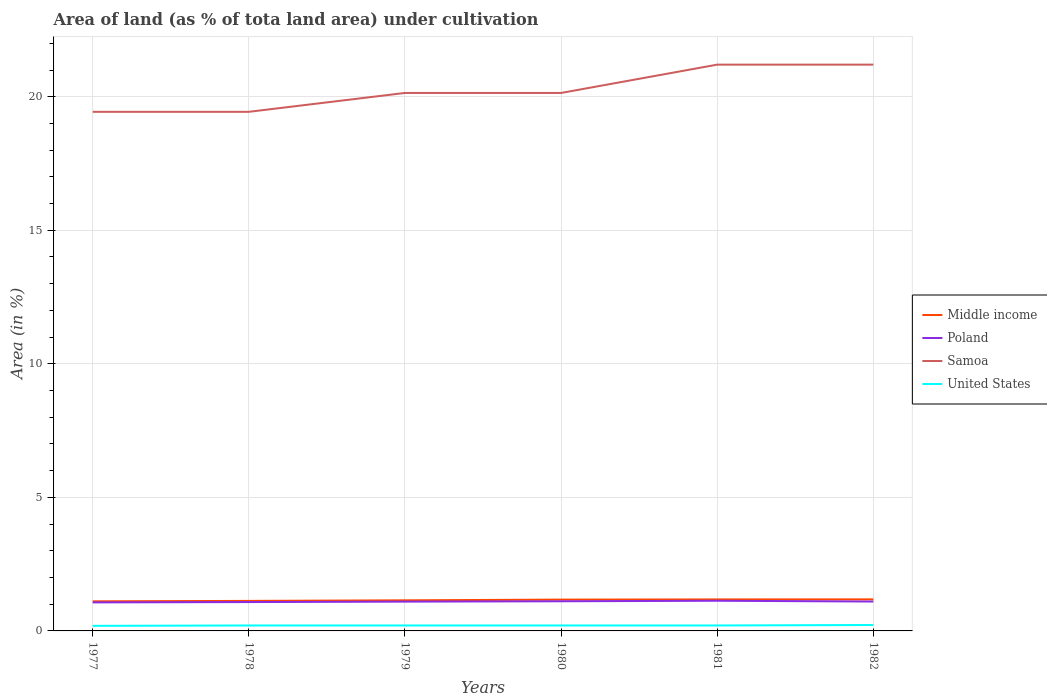How many different coloured lines are there?
Make the answer very short. 4. Does the line corresponding to United States intersect with the line corresponding to Poland?
Offer a terse response. No. Across all years, what is the maximum percentage of land under cultivation in United States?
Your answer should be compact. 0.19. What is the total percentage of land under cultivation in Samoa in the graph?
Your answer should be very brief. -0.71. What is the difference between the highest and the second highest percentage of land under cultivation in Poland?
Offer a very short reply. 0.06. What is the difference between the highest and the lowest percentage of land under cultivation in Middle income?
Offer a very short reply. 3. How many lines are there?
Keep it short and to the point. 4. How many years are there in the graph?
Make the answer very short. 6. Does the graph contain any zero values?
Ensure brevity in your answer.  No. How many legend labels are there?
Ensure brevity in your answer.  4. What is the title of the graph?
Offer a very short reply. Area of land (as % of tota land area) under cultivation. Does "Rwanda" appear as one of the legend labels in the graph?
Keep it short and to the point. No. What is the label or title of the X-axis?
Offer a terse response. Years. What is the label or title of the Y-axis?
Offer a terse response. Area (in %). What is the Area (in %) in Middle income in 1977?
Offer a very short reply. 1.11. What is the Area (in %) in Poland in 1977?
Provide a short and direct response. 1.07. What is the Area (in %) in Samoa in 1977?
Provide a succinct answer. 19.43. What is the Area (in %) of United States in 1977?
Your response must be concise. 0.19. What is the Area (in %) of Middle income in 1978?
Keep it short and to the point. 1.12. What is the Area (in %) in Poland in 1978?
Offer a terse response. 1.08. What is the Area (in %) of Samoa in 1978?
Make the answer very short. 19.43. What is the Area (in %) in United States in 1978?
Offer a terse response. 0.2. What is the Area (in %) of Middle income in 1979?
Keep it short and to the point. 1.15. What is the Area (in %) in Poland in 1979?
Offer a very short reply. 1.1. What is the Area (in %) of Samoa in 1979?
Keep it short and to the point. 20.14. What is the Area (in %) of United States in 1979?
Provide a short and direct response. 0.2. What is the Area (in %) in Middle income in 1980?
Your answer should be compact. 1.17. What is the Area (in %) in Poland in 1980?
Your answer should be very brief. 1.11. What is the Area (in %) of Samoa in 1980?
Keep it short and to the point. 20.14. What is the Area (in %) in United States in 1980?
Ensure brevity in your answer.  0.2. What is the Area (in %) of Middle income in 1981?
Your answer should be very brief. 1.18. What is the Area (in %) in Poland in 1981?
Provide a short and direct response. 1.13. What is the Area (in %) in Samoa in 1981?
Give a very brief answer. 21.2. What is the Area (in %) in United States in 1981?
Offer a terse response. 0.2. What is the Area (in %) of Middle income in 1982?
Offer a very short reply. 1.18. What is the Area (in %) of Poland in 1982?
Provide a succinct answer. 1.1. What is the Area (in %) in Samoa in 1982?
Provide a succinct answer. 21.2. What is the Area (in %) of United States in 1982?
Offer a terse response. 0.22. Across all years, what is the maximum Area (in %) in Middle income?
Offer a terse response. 1.18. Across all years, what is the maximum Area (in %) of Poland?
Offer a very short reply. 1.13. Across all years, what is the maximum Area (in %) in Samoa?
Offer a very short reply. 21.2. Across all years, what is the maximum Area (in %) of United States?
Keep it short and to the point. 0.22. Across all years, what is the minimum Area (in %) in Middle income?
Keep it short and to the point. 1.11. Across all years, what is the minimum Area (in %) in Poland?
Offer a terse response. 1.07. Across all years, what is the minimum Area (in %) of Samoa?
Offer a terse response. 19.43. Across all years, what is the minimum Area (in %) of United States?
Offer a very short reply. 0.19. What is the total Area (in %) of Middle income in the graph?
Your answer should be compact. 6.91. What is the total Area (in %) in Poland in the graph?
Your response must be concise. 6.59. What is the total Area (in %) of Samoa in the graph?
Offer a terse response. 121.55. What is the total Area (in %) of United States in the graph?
Your answer should be compact. 1.23. What is the difference between the Area (in %) in Middle income in 1977 and that in 1978?
Ensure brevity in your answer.  -0.02. What is the difference between the Area (in %) in Poland in 1977 and that in 1978?
Offer a terse response. -0.01. What is the difference between the Area (in %) of Samoa in 1977 and that in 1978?
Provide a short and direct response. 0. What is the difference between the Area (in %) of United States in 1977 and that in 1978?
Your answer should be very brief. -0.01. What is the difference between the Area (in %) in Middle income in 1977 and that in 1979?
Your response must be concise. -0.04. What is the difference between the Area (in %) of Poland in 1977 and that in 1979?
Ensure brevity in your answer.  -0.03. What is the difference between the Area (in %) of Samoa in 1977 and that in 1979?
Your answer should be very brief. -0.71. What is the difference between the Area (in %) of United States in 1977 and that in 1979?
Make the answer very short. -0.01. What is the difference between the Area (in %) in Middle income in 1977 and that in 1980?
Give a very brief answer. -0.06. What is the difference between the Area (in %) of Poland in 1977 and that in 1980?
Offer a very short reply. -0.04. What is the difference between the Area (in %) of Samoa in 1977 and that in 1980?
Your answer should be compact. -0.71. What is the difference between the Area (in %) of United States in 1977 and that in 1980?
Your answer should be compact. -0.01. What is the difference between the Area (in %) in Middle income in 1977 and that in 1981?
Ensure brevity in your answer.  -0.07. What is the difference between the Area (in %) of Poland in 1977 and that in 1981?
Your response must be concise. -0.06. What is the difference between the Area (in %) of Samoa in 1977 and that in 1981?
Offer a very short reply. -1.77. What is the difference between the Area (in %) in United States in 1977 and that in 1981?
Your answer should be compact. -0.01. What is the difference between the Area (in %) in Middle income in 1977 and that in 1982?
Give a very brief answer. -0.07. What is the difference between the Area (in %) in Poland in 1977 and that in 1982?
Give a very brief answer. -0.03. What is the difference between the Area (in %) of Samoa in 1977 and that in 1982?
Provide a succinct answer. -1.77. What is the difference between the Area (in %) in United States in 1977 and that in 1982?
Your response must be concise. -0.03. What is the difference between the Area (in %) of Middle income in 1978 and that in 1979?
Keep it short and to the point. -0.02. What is the difference between the Area (in %) of Poland in 1978 and that in 1979?
Keep it short and to the point. -0.02. What is the difference between the Area (in %) of Samoa in 1978 and that in 1979?
Your answer should be very brief. -0.71. What is the difference between the Area (in %) of United States in 1978 and that in 1979?
Your answer should be very brief. 0. What is the difference between the Area (in %) of Middle income in 1978 and that in 1980?
Provide a succinct answer. -0.05. What is the difference between the Area (in %) of Poland in 1978 and that in 1980?
Your answer should be very brief. -0.03. What is the difference between the Area (in %) of Samoa in 1978 and that in 1980?
Provide a short and direct response. -0.71. What is the difference between the Area (in %) of Middle income in 1978 and that in 1981?
Your answer should be compact. -0.06. What is the difference between the Area (in %) in Poland in 1978 and that in 1981?
Give a very brief answer. -0.05. What is the difference between the Area (in %) of Samoa in 1978 and that in 1981?
Your answer should be compact. -1.77. What is the difference between the Area (in %) of Middle income in 1978 and that in 1982?
Your answer should be compact. -0.06. What is the difference between the Area (in %) of Poland in 1978 and that in 1982?
Offer a terse response. -0.02. What is the difference between the Area (in %) of Samoa in 1978 and that in 1982?
Provide a short and direct response. -1.77. What is the difference between the Area (in %) of United States in 1978 and that in 1982?
Your answer should be compact. -0.02. What is the difference between the Area (in %) of Middle income in 1979 and that in 1980?
Your answer should be compact. -0.03. What is the difference between the Area (in %) of Poland in 1979 and that in 1980?
Your answer should be compact. -0.01. What is the difference between the Area (in %) in United States in 1979 and that in 1980?
Offer a terse response. 0. What is the difference between the Area (in %) in Middle income in 1979 and that in 1981?
Your response must be concise. -0.03. What is the difference between the Area (in %) of Poland in 1979 and that in 1981?
Make the answer very short. -0.03. What is the difference between the Area (in %) of Samoa in 1979 and that in 1981?
Give a very brief answer. -1.06. What is the difference between the Area (in %) of Middle income in 1979 and that in 1982?
Offer a very short reply. -0.04. What is the difference between the Area (in %) of Poland in 1979 and that in 1982?
Your answer should be compact. -0. What is the difference between the Area (in %) of Samoa in 1979 and that in 1982?
Your response must be concise. -1.06. What is the difference between the Area (in %) of United States in 1979 and that in 1982?
Your response must be concise. -0.02. What is the difference between the Area (in %) of Middle income in 1980 and that in 1981?
Make the answer very short. -0.01. What is the difference between the Area (in %) in Poland in 1980 and that in 1981?
Keep it short and to the point. -0.02. What is the difference between the Area (in %) in Samoa in 1980 and that in 1981?
Your answer should be very brief. -1.06. What is the difference between the Area (in %) in United States in 1980 and that in 1981?
Offer a very short reply. 0. What is the difference between the Area (in %) in Middle income in 1980 and that in 1982?
Ensure brevity in your answer.  -0.01. What is the difference between the Area (in %) of Poland in 1980 and that in 1982?
Offer a terse response. 0.01. What is the difference between the Area (in %) in Samoa in 1980 and that in 1982?
Provide a short and direct response. -1.06. What is the difference between the Area (in %) of United States in 1980 and that in 1982?
Ensure brevity in your answer.  -0.02. What is the difference between the Area (in %) in Middle income in 1981 and that in 1982?
Your response must be concise. -0. What is the difference between the Area (in %) in Poland in 1981 and that in 1982?
Ensure brevity in your answer.  0.03. What is the difference between the Area (in %) of Samoa in 1981 and that in 1982?
Provide a succinct answer. 0. What is the difference between the Area (in %) of United States in 1981 and that in 1982?
Give a very brief answer. -0.02. What is the difference between the Area (in %) in Middle income in 1977 and the Area (in %) in Poland in 1978?
Provide a succinct answer. 0.03. What is the difference between the Area (in %) of Middle income in 1977 and the Area (in %) of Samoa in 1978?
Give a very brief answer. -18.33. What is the difference between the Area (in %) in Middle income in 1977 and the Area (in %) in United States in 1978?
Keep it short and to the point. 0.9. What is the difference between the Area (in %) of Poland in 1977 and the Area (in %) of Samoa in 1978?
Your answer should be compact. -18.37. What is the difference between the Area (in %) in Poland in 1977 and the Area (in %) in United States in 1978?
Offer a very short reply. 0.86. What is the difference between the Area (in %) in Samoa in 1977 and the Area (in %) in United States in 1978?
Ensure brevity in your answer.  19.23. What is the difference between the Area (in %) of Middle income in 1977 and the Area (in %) of Poland in 1979?
Offer a very short reply. 0.01. What is the difference between the Area (in %) of Middle income in 1977 and the Area (in %) of Samoa in 1979?
Provide a succinct answer. -19.03. What is the difference between the Area (in %) of Middle income in 1977 and the Area (in %) of United States in 1979?
Ensure brevity in your answer.  0.9. What is the difference between the Area (in %) in Poland in 1977 and the Area (in %) in Samoa in 1979?
Your answer should be very brief. -19.07. What is the difference between the Area (in %) in Poland in 1977 and the Area (in %) in United States in 1979?
Keep it short and to the point. 0.86. What is the difference between the Area (in %) of Samoa in 1977 and the Area (in %) of United States in 1979?
Your response must be concise. 19.23. What is the difference between the Area (in %) in Middle income in 1977 and the Area (in %) in Poland in 1980?
Ensure brevity in your answer.  -0. What is the difference between the Area (in %) of Middle income in 1977 and the Area (in %) of Samoa in 1980?
Your response must be concise. -19.03. What is the difference between the Area (in %) in Middle income in 1977 and the Area (in %) in United States in 1980?
Ensure brevity in your answer.  0.9. What is the difference between the Area (in %) in Poland in 1977 and the Area (in %) in Samoa in 1980?
Offer a terse response. -19.07. What is the difference between the Area (in %) in Poland in 1977 and the Area (in %) in United States in 1980?
Provide a short and direct response. 0.86. What is the difference between the Area (in %) in Samoa in 1977 and the Area (in %) in United States in 1980?
Offer a terse response. 19.23. What is the difference between the Area (in %) in Middle income in 1977 and the Area (in %) in Poland in 1981?
Give a very brief answer. -0.02. What is the difference between the Area (in %) of Middle income in 1977 and the Area (in %) of Samoa in 1981?
Your answer should be very brief. -20.09. What is the difference between the Area (in %) in Middle income in 1977 and the Area (in %) in United States in 1981?
Your answer should be very brief. 0.9. What is the difference between the Area (in %) in Poland in 1977 and the Area (in %) in Samoa in 1981?
Provide a short and direct response. -20.13. What is the difference between the Area (in %) of Poland in 1977 and the Area (in %) of United States in 1981?
Your answer should be compact. 0.86. What is the difference between the Area (in %) of Samoa in 1977 and the Area (in %) of United States in 1981?
Your response must be concise. 19.23. What is the difference between the Area (in %) of Middle income in 1977 and the Area (in %) of Poland in 1982?
Give a very brief answer. 0.01. What is the difference between the Area (in %) of Middle income in 1977 and the Area (in %) of Samoa in 1982?
Your answer should be compact. -20.09. What is the difference between the Area (in %) of Middle income in 1977 and the Area (in %) of United States in 1982?
Ensure brevity in your answer.  0.89. What is the difference between the Area (in %) in Poland in 1977 and the Area (in %) in Samoa in 1982?
Make the answer very short. -20.13. What is the difference between the Area (in %) of Poland in 1977 and the Area (in %) of United States in 1982?
Offer a terse response. 0.85. What is the difference between the Area (in %) of Samoa in 1977 and the Area (in %) of United States in 1982?
Your answer should be compact. 19.21. What is the difference between the Area (in %) in Middle income in 1978 and the Area (in %) in Poland in 1979?
Your response must be concise. 0.03. What is the difference between the Area (in %) in Middle income in 1978 and the Area (in %) in Samoa in 1979?
Ensure brevity in your answer.  -19.02. What is the difference between the Area (in %) of Middle income in 1978 and the Area (in %) of United States in 1979?
Keep it short and to the point. 0.92. What is the difference between the Area (in %) of Poland in 1978 and the Area (in %) of Samoa in 1979?
Give a very brief answer. -19.06. What is the difference between the Area (in %) of Poland in 1978 and the Area (in %) of United States in 1979?
Your answer should be very brief. 0.88. What is the difference between the Area (in %) of Samoa in 1978 and the Area (in %) of United States in 1979?
Your answer should be compact. 19.23. What is the difference between the Area (in %) in Middle income in 1978 and the Area (in %) in Poland in 1980?
Give a very brief answer. 0.01. What is the difference between the Area (in %) in Middle income in 1978 and the Area (in %) in Samoa in 1980?
Ensure brevity in your answer.  -19.02. What is the difference between the Area (in %) in Middle income in 1978 and the Area (in %) in United States in 1980?
Ensure brevity in your answer.  0.92. What is the difference between the Area (in %) in Poland in 1978 and the Area (in %) in Samoa in 1980?
Your answer should be very brief. -19.06. What is the difference between the Area (in %) of Poland in 1978 and the Area (in %) of United States in 1980?
Make the answer very short. 0.88. What is the difference between the Area (in %) of Samoa in 1978 and the Area (in %) of United States in 1980?
Your answer should be compact. 19.23. What is the difference between the Area (in %) in Middle income in 1978 and the Area (in %) in Poland in 1981?
Your response must be concise. -0.01. What is the difference between the Area (in %) in Middle income in 1978 and the Area (in %) in Samoa in 1981?
Your answer should be compact. -20.08. What is the difference between the Area (in %) in Middle income in 1978 and the Area (in %) in United States in 1981?
Your response must be concise. 0.92. What is the difference between the Area (in %) in Poland in 1978 and the Area (in %) in Samoa in 1981?
Your answer should be compact. -20.12. What is the difference between the Area (in %) in Poland in 1978 and the Area (in %) in United States in 1981?
Give a very brief answer. 0.88. What is the difference between the Area (in %) of Samoa in 1978 and the Area (in %) of United States in 1981?
Your answer should be very brief. 19.23. What is the difference between the Area (in %) of Middle income in 1978 and the Area (in %) of Poland in 1982?
Your response must be concise. 0.02. What is the difference between the Area (in %) in Middle income in 1978 and the Area (in %) in Samoa in 1982?
Your response must be concise. -20.08. What is the difference between the Area (in %) of Middle income in 1978 and the Area (in %) of United States in 1982?
Your answer should be compact. 0.9. What is the difference between the Area (in %) in Poland in 1978 and the Area (in %) in Samoa in 1982?
Your answer should be very brief. -20.12. What is the difference between the Area (in %) of Poland in 1978 and the Area (in %) of United States in 1982?
Your response must be concise. 0.86. What is the difference between the Area (in %) of Samoa in 1978 and the Area (in %) of United States in 1982?
Keep it short and to the point. 19.21. What is the difference between the Area (in %) of Middle income in 1979 and the Area (in %) of Poland in 1980?
Make the answer very short. 0.04. What is the difference between the Area (in %) of Middle income in 1979 and the Area (in %) of Samoa in 1980?
Offer a very short reply. -19. What is the difference between the Area (in %) in Middle income in 1979 and the Area (in %) in United States in 1980?
Your answer should be compact. 0.94. What is the difference between the Area (in %) in Poland in 1979 and the Area (in %) in Samoa in 1980?
Offer a terse response. -19.04. What is the difference between the Area (in %) of Poland in 1979 and the Area (in %) of United States in 1980?
Provide a succinct answer. 0.89. What is the difference between the Area (in %) in Samoa in 1979 and the Area (in %) in United States in 1980?
Make the answer very short. 19.94. What is the difference between the Area (in %) in Middle income in 1979 and the Area (in %) in Poland in 1981?
Make the answer very short. 0.02. What is the difference between the Area (in %) of Middle income in 1979 and the Area (in %) of Samoa in 1981?
Offer a terse response. -20.06. What is the difference between the Area (in %) in Middle income in 1979 and the Area (in %) in United States in 1981?
Offer a terse response. 0.94. What is the difference between the Area (in %) in Poland in 1979 and the Area (in %) in Samoa in 1981?
Give a very brief answer. -20.1. What is the difference between the Area (in %) in Poland in 1979 and the Area (in %) in United States in 1981?
Provide a succinct answer. 0.89. What is the difference between the Area (in %) in Samoa in 1979 and the Area (in %) in United States in 1981?
Make the answer very short. 19.94. What is the difference between the Area (in %) of Middle income in 1979 and the Area (in %) of Poland in 1982?
Provide a succinct answer. 0.05. What is the difference between the Area (in %) in Middle income in 1979 and the Area (in %) in Samoa in 1982?
Your answer should be compact. -20.06. What is the difference between the Area (in %) in Middle income in 1979 and the Area (in %) in United States in 1982?
Your answer should be very brief. 0.92. What is the difference between the Area (in %) in Poland in 1979 and the Area (in %) in Samoa in 1982?
Give a very brief answer. -20.1. What is the difference between the Area (in %) of Poland in 1979 and the Area (in %) of United States in 1982?
Provide a succinct answer. 0.87. What is the difference between the Area (in %) in Samoa in 1979 and the Area (in %) in United States in 1982?
Give a very brief answer. 19.92. What is the difference between the Area (in %) of Middle income in 1980 and the Area (in %) of Poland in 1981?
Your response must be concise. 0.04. What is the difference between the Area (in %) of Middle income in 1980 and the Area (in %) of Samoa in 1981?
Provide a short and direct response. -20.03. What is the difference between the Area (in %) in Middle income in 1980 and the Area (in %) in United States in 1981?
Provide a short and direct response. 0.97. What is the difference between the Area (in %) of Poland in 1980 and the Area (in %) of Samoa in 1981?
Offer a very short reply. -20.09. What is the difference between the Area (in %) of Poland in 1980 and the Area (in %) of United States in 1981?
Ensure brevity in your answer.  0.91. What is the difference between the Area (in %) of Samoa in 1980 and the Area (in %) of United States in 1981?
Ensure brevity in your answer.  19.94. What is the difference between the Area (in %) in Middle income in 1980 and the Area (in %) in Poland in 1982?
Your answer should be very brief. 0.07. What is the difference between the Area (in %) of Middle income in 1980 and the Area (in %) of Samoa in 1982?
Ensure brevity in your answer.  -20.03. What is the difference between the Area (in %) in Middle income in 1980 and the Area (in %) in United States in 1982?
Your answer should be compact. 0.95. What is the difference between the Area (in %) of Poland in 1980 and the Area (in %) of Samoa in 1982?
Make the answer very short. -20.09. What is the difference between the Area (in %) in Poland in 1980 and the Area (in %) in United States in 1982?
Offer a terse response. 0.89. What is the difference between the Area (in %) of Samoa in 1980 and the Area (in %) of United States in 1982?
Your answer should be very brief. 19.92. What is the difference between the Area (in %) of Middle income in 1981 and the Area (in %) of Poland in 1982?
Offer a terse response. 0.08. What is the difference between the Area (in %) in Middle income in 1981 and the Area (in %) in Samoa in 1982?
Provide a short and direct response. -20.02. What is the difference between the Area (in %) of Middle income in 1981 and the Area (in %) of United States in 1982?
Your answer should be very brief. 0.96. What is the difference between the Area (in %) of Poland in 1981 and the Area (in %) of Samoa in 1982?
Your answer should be compact. -20.07. What is the difference between the Area (in %) of Poland in 1981 and the Area (in %) of United States in 1982?
Give a very brief answer. 0.91. What is the difference between the Area (in %) in Samoa in 1981 and the Area (in %) in United States in 1982?
Your answer should be compact. 20.98. What is the average Area (in %) in Middle income per year?
Provide a short and direct response. 1.15. What is the average Area (in %) of Poland per year?
Ensure brevity in your answer.  1.1. What is the average Area (in %) of Samoa per year?
Give a very brief answer. 20.26. What is the average Area (in %) of United States per year?
Provide a succinct answer. 0.2. In the year 1977, what is the difference between the Area (in %) in Middle income and Area (in %) in Poland?
Offer a terse response. 0.04. In the year 1977, what is the difference between the Area (in %) of Middle income and Area (in %) of Samoa?
Offer a terse response. -18.33. In the year 1977, what is the difference between the Area (in %) in Middle income and Area (in %) in United States?
Provide a succinct answer. 0.92. In the year 1977, what is the difference between the Area (in %) of Poland and Area (in %) of Samoa?
Make the answer very short. -18.37. In the year 1977, what is the difference between the Area (in %) of Poland and Area (in %) of United States?
Offer a terse response. 0.88. In the year 1977, what is the difference between the Area (in %) in Samoa and Area (in %) in United States?
Offer a very short reply. 19.24. In the year 1978, what is the difference between the Area (in %) in Middle income and Area (in %) in Poland?
Offer a very short reply. 0.04. In the year 1978, what is the difference between the Area (in %) in Middle income and Area (in %) in Samoa?
Give a very brief answer. -18.31. In the year 1978, what is the difference between the Area (in %) in Middle income and Area (in %) in United States?
Provide a succinct answer. 0.92. In the year 1978, what is the difference between the Area (in %) in Poland and Area (in %) in Samoa?
Your response must be concise. -18.35. In the year 1978, what is the difference between the Area (in %) in Poland and Area (in %) in United States?
Your answer should be very brief. 0.88. In the year 1978, what is the difference between the Area (in %) of Samoa and Area (in %) of United States?
Provide a short and direct response. 19.23. In the year 1979, what is the difference between the Area (in %) of Middle income and Area (in %) of Poland?
Offer a terse response. 0.05. In the year 1979, what is the difference between the Area (in %) of Middle income and Area (in %) of Samoa?
Ensure brevity in your answer.  -19. In the year 1979, what is the difference between the Area (in %) of Middle income and Area (in %) of United States?
Your answer should be compact. 0.94. In the year 1979, what is the difference between the Area (in %) of Poland and Area (in %) of Samoa?
Provide a short and direct response. -19.04. In the year 1979, what is the difference between the Area (in %) of Poland and Area (in %) of United States?
Your response must be concise. 0.89. In the year 1979, what is the difference between the Area (in %) of Samoa and Area (in %) of United States?
Ensure brevity in your answer.  19.94. In the year 1980, what is the difference between the Area (in %) of Middle income and Area (in %) of Poland?
Make the answer very short. 0.06. In the year 1980, what is the difference between the Area (in %) in Middle income and Area (in %) in Samoa?
Your answer should be compact. -18.97. In the year 1980, what is the difference between the Area (in %) in Middle income and Area (in %) in United States?
Offer a terse response. 0.97. In the year 1980, what is the difference between the Area (in %) in Poland and Area (in %) in Samoa?
Your response must be concise. -19.03. In the year 1980, what is the difference between the Area (in %) of Poland and Area (in %) of United States?
Make the answer very short. 0.91. In the year 1980, what is the difference between the Area (in %) of Samoa and Area (in %) of United States?
Your answer should be very brief. 19.94. In the year 1981, what is the difference between the Area (in %) in Middle income and Area (in %) in Poland?
Offer a very short reply. 0.05. In the year 1981, what is the difference between the Area (in %) of Middle income and Area (in %) of Samoa?
Give a very brief answer. -20.02. In the year 1981, what is the difference between the Area (in %) of Middle income and Area (in %) of United States?
Your answer should be very brief. 0.98. In the year 1981, what is the difference between the Area (in %) of Poland and Area (in %) of Samoa?
Ensure brevity in your answer.  -20.07. In the year 1981, what is the difference between the Area (in %) in Poland and Area (in %) in United States?
Give a very brief answer. 0.93. In the year 1981, what is the difference between the Area (in %) of Samoa and Area (in %) of United States?
Make the answer very short. 21. In the year 1982, what is the difference between the Area (in %) of Middle income and Area (in %) of Poland?
Give a very brief answer. 0.08. In the year 1982, what is the difference between the Area (in %) in Middle income and Area (in %) in Samoa?
Your response must be concise. -20.02. In the year 1982, what is the difference between the Area (in %) of Middle income and Area (in %) of United States?
Keep it short and to the point. 0.96. In the year 1982, what is the difference between the Area (in %) of Poland and Area (in %) of Samoa?
Offer a very short reply. -20.1. In the year 1982, what is the difference between the Area (in %) of Poland and Area (in %) of United States?
Your answer should be compact. 0.88. In the year 1982, what is the difference between the Area (in %) in Samoa and Area (in %) in United States?
Give a very brief answer. 20.98. What is the ratio of the Area (in %) of Middle income in 1977 to that in 1978?
Provide a succinct answer. 0.99. What is the ratio of the Area (in %) in Poland in 1977 to that in 1978?
Your answer should be compact. 0.99. What is the ratio of the Area (in %) of United States in 1977 to that in 1978?
Provide a short and direct response. 0.93. What is the ratio of the Area (in %) in Middle income in 1977 to that in 1979?
Your response must be concise. 0.97. What is the ratio of the Area (in %) of Poland in 1977 to that in 1979?
Provide a short and direct response. 0.97. What is the ratio of the Area (in %) in Samoa in 1977 to that in 1979?
Offer a very short reply. 0.96. What is the ratio of the Area (in %) in United States in 1977 to that in 1979?
Keep it short and to the point. 0.93. What is the ratio of the Area (in %) of Middle income in 1977 to that in 1980?
Your response must be concise. 0.94. What is the ratio of the Area (in %) in Poland in 1977 to that in 1980?
Ensure brevity in your answer.  0.96. What is the ratio of the Area (in %) of Samoa in 1977 to that in 1980?
Ensure brevity in your answer.  0.96. What is the ratio of the Area (in %) in United States in 1977 to that in 1980?
Offer a very short reply. 0.93. What is the ratio of the Area (in %) in Middle income in 1977 to that in 1981?
Provide a succinct answer. 0.94. What is the ratio of the Area (in %) of Poland in 1977 to that in 1981?
Keep it short and to the point. 0.95. What is the ratio of the Area (in %) in United States in 1977 to that in 1981?
Offer a very short reply. 0.93. What is the ratio of the Area (in %) in Middle income in 1977 to that in 1982?
Provide a short and direct response. 0.94. What is the ratio of the Area (in %) in Poland in 1977 to that in 1982?
Your response must be concise. 0.97. What is the ratio of the Area (in %) in Samoa in 1977 to that in 1982?
Make the answer very short. 0.92. What is the ratio of the Area (in %) in United States in 1977 to that in 1982?
Offer a very short reply. 0.86. What is the ratio of the Area (in %) in Middle income in 1978 to that in 1979?
Keep it short and to the point. 0.98. What is the ratio of the Area (in %) in Poland in 1978 to that in 1979?
Give a very brief answer. 0.99. What is the ratio of the Area (in %) in Samoa in 1978 to that in 1979?
Provide a short and direct response. 0.96. What is the ratio of the Area (in %) of Middle income in 1978 to that in 1980?
Provide a succinct answer. 0.96. What is the ratio of the Area (in %) of Poland in 1978 to that in 1980?
Your answer should be very brief. 0.97. What is the ratio of the Area (in %) in Samoa in 1978 to that in 1980?
Give a very brief answer. 0.96. What is the ratio of the Area (in %) in United States in 1978 to that in 1980?
Offer a very short reply. 1. What is the ratio of the Area (in %) in Middle income in 1978 to that in 1981?
Provide a short and direct response. 0.95. What is the ratio of the Area (in %) of Poland in 1978 to that in 1981?
Offer a very short reply. 0.96. What is the ratio of the Area (in %) in Middle income in 1978 to that in 1982?
Give a very brief answer. 0.95. What is the ratio of the Area (in %) of Poland in 1978 to that in 1982?
Give a very brief answer. 0.98. What is the ratio of the Area (in %) of Samoa in 1978 to that in 1982?
Make the answer very short. 0.92. What is the ratio of the Area (in %) of United States in 1978 to that in 1982?
Your response must be concise. 0.92. What is the ratio of the Area (in %) of Middle income in 1979 to that in 1980?
Your answer should be compact. 0.98. What is the ratio of the Area (in %) in United States in 1979 to that in 1980?
Provide a short and direct response. 1. What is the ratio of the Area (in %) of Middle income in 1979 to that in 1981?
Your answer should be very brief. 0.97. What is the ratio of the Area (in %) of Poland in 1979 to that in 1981?
Keep it short and to the point. 0.97. What is the ratio of the Area (in %) of Samoa in 1979 to that in 1981?
Give a very brief answer. 0.95. What is the ratio of the Area (in %) of United States in 1979 to that in 1981?
Offer a terse response. 1. What is the ratio of the Area (in %) in Middle income in 1979 to that in 1982?
Your response must be concise. 0.97. What is the ratio of the Area (in %) of Poland in 1979 to that in 1982?
Make the answer very short. 1. What is the ratio of the Area (in %) of United States in 1979 to that in 1982?
Give a very brief answer. 0.92. What is the ratio of the Area (in %) in Middle income in 1980 to that in 1981?
Offer a terse response. 0.99. What is the ratio of the Area (in %) in Poland in 1980 to that in 1981?
Your response must be concise. 0.98. What is the ratio of the Area (in %) of Samoa in 1980 to that in 1981?
Your answer should be very brief. 0.95. What is the ratio of the Area (in %) of United States in 1980 to that in 1981?
Keep it short and to the point. 1. What is the ratio of the Area (in %) of Poland in 1980 to that in 1982?
Your answer should be very brief. 1.01. What is the ratio of the Area (in %) of United States in 1980 to that in 1982?
Your response must be concise. 0.92. What is the ratio of the Area (in %) in Middle income in 1981 to that in 1982?
Your answer should be compact. 1. What is the ratio of the Area (in %) in Poland in 1981 to that in 1982?
Make the answer very short. 1.03. What is the ratio of the Area (in %) in United States in 1981 to that in 1982?
Provide a short and direct response. 0.92. What is the difference between the highest and the second highest Area (in %) of Middle income?
Provide a succinct answer. 0. What is the difference between the highest and the second highest Area (in %) in Poland?
Offer a terse response. 0.02. What is the difference between the highest and the second highest Area (in %) in Samoa?
Provide a succinct answer. 0. What is the difference between the highest and the second highest Area (in %) of United States?
Keep it short and to the point. 0.02. What is the difference between the highest and the lowest Area (in %) in Middle income?
Your answer should be very brief. 0.07. What is the difference between the highest and the lowest Area (in %) of Poland?
Offer a very short reply. 0.06. What is the difference between the highest and the lowest Area (in %) in Samoa?
Offer a terse response. 1.77. What is the difference between the highest and the lowest Area (in %) of United States?
Offer a terse response. 0.03. 